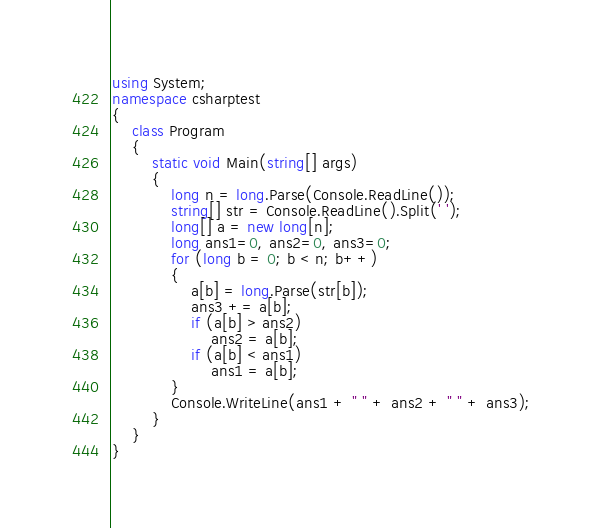Convert code to text. <code><loc_0><loc_0><loc_500><loc_500><_C#_>using System;
namespace csharptest
{
    class Program
    {
        static void Main(string[] args)
        {
            long n = long.Parse(Console.ReadLine());
            string[] str = Console.ReadLine().Split(' ');
            long[] a = new long[n];
            long ans1=0, ans2=0, ans3=0;
            for (long b = 0; b < n; b++)
            {
                a[b] = long.Parse(str[b]);
                ans3 += a[b];
                if (a[b] > ans2)
                    ans2 = a[b];
                if (a[b] < ans1)
                    ans1 = a[b];
            }
            Console.WriteLine(ans1 + " " + ans2 + " " + ans3);
        }
    }
}</code> 